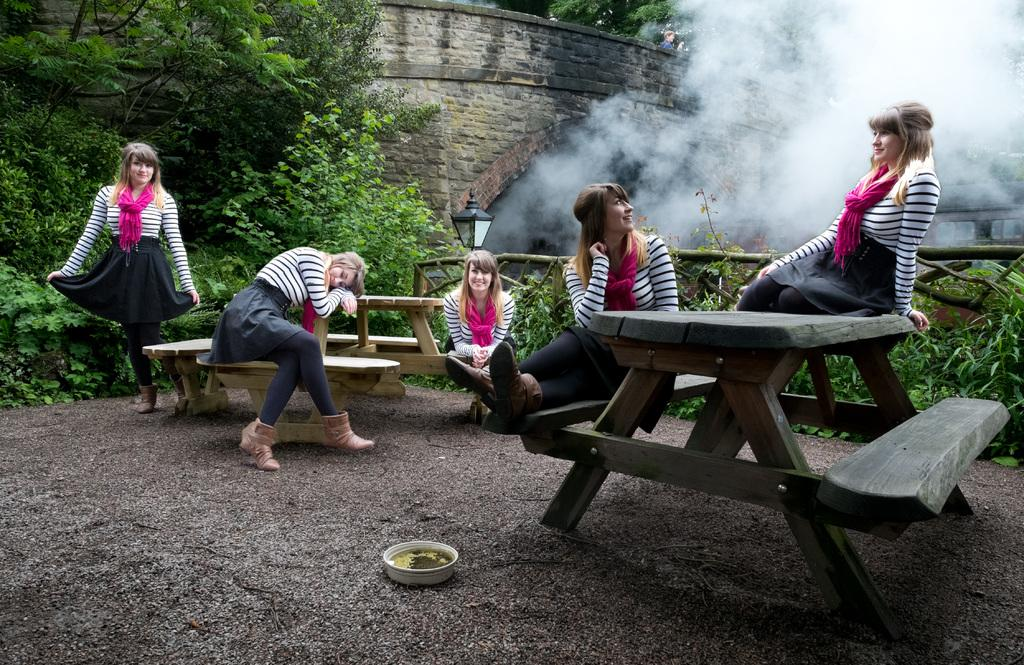Who is the main subject in the image? There is a lady in the image. What is unique about the lady's appearance in the image? The lady has duplicate images of her in various positions. What is the lady doing in the image? The lady is sitting and standing on a bench. What can be seen in the background of the image? There are trees and a tunnel in the background of the image. What is happening with the tunnel in the image? Smoke is coming out of the tunnel. What statement does the lady make in the image? There is no dialogue or statement made by the lady in the image. What type of notebook is the lady holding in the image? There is no notebook present in the image. 